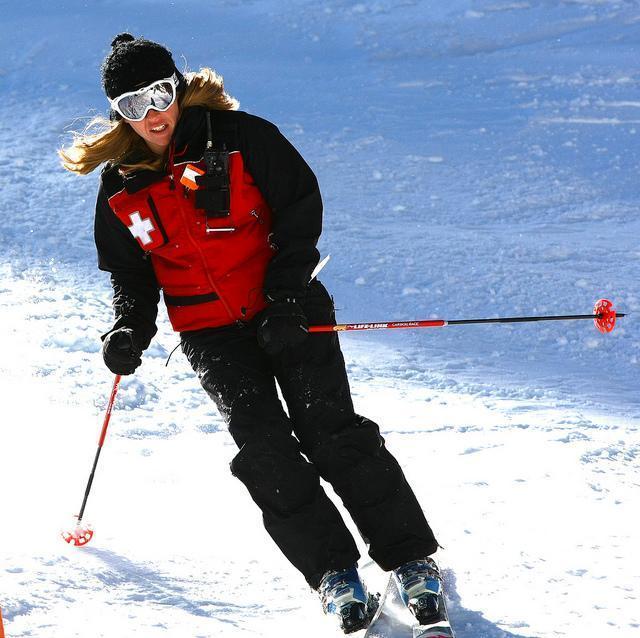How many bikes are in this photo?
Give a very brief answer. 0. 